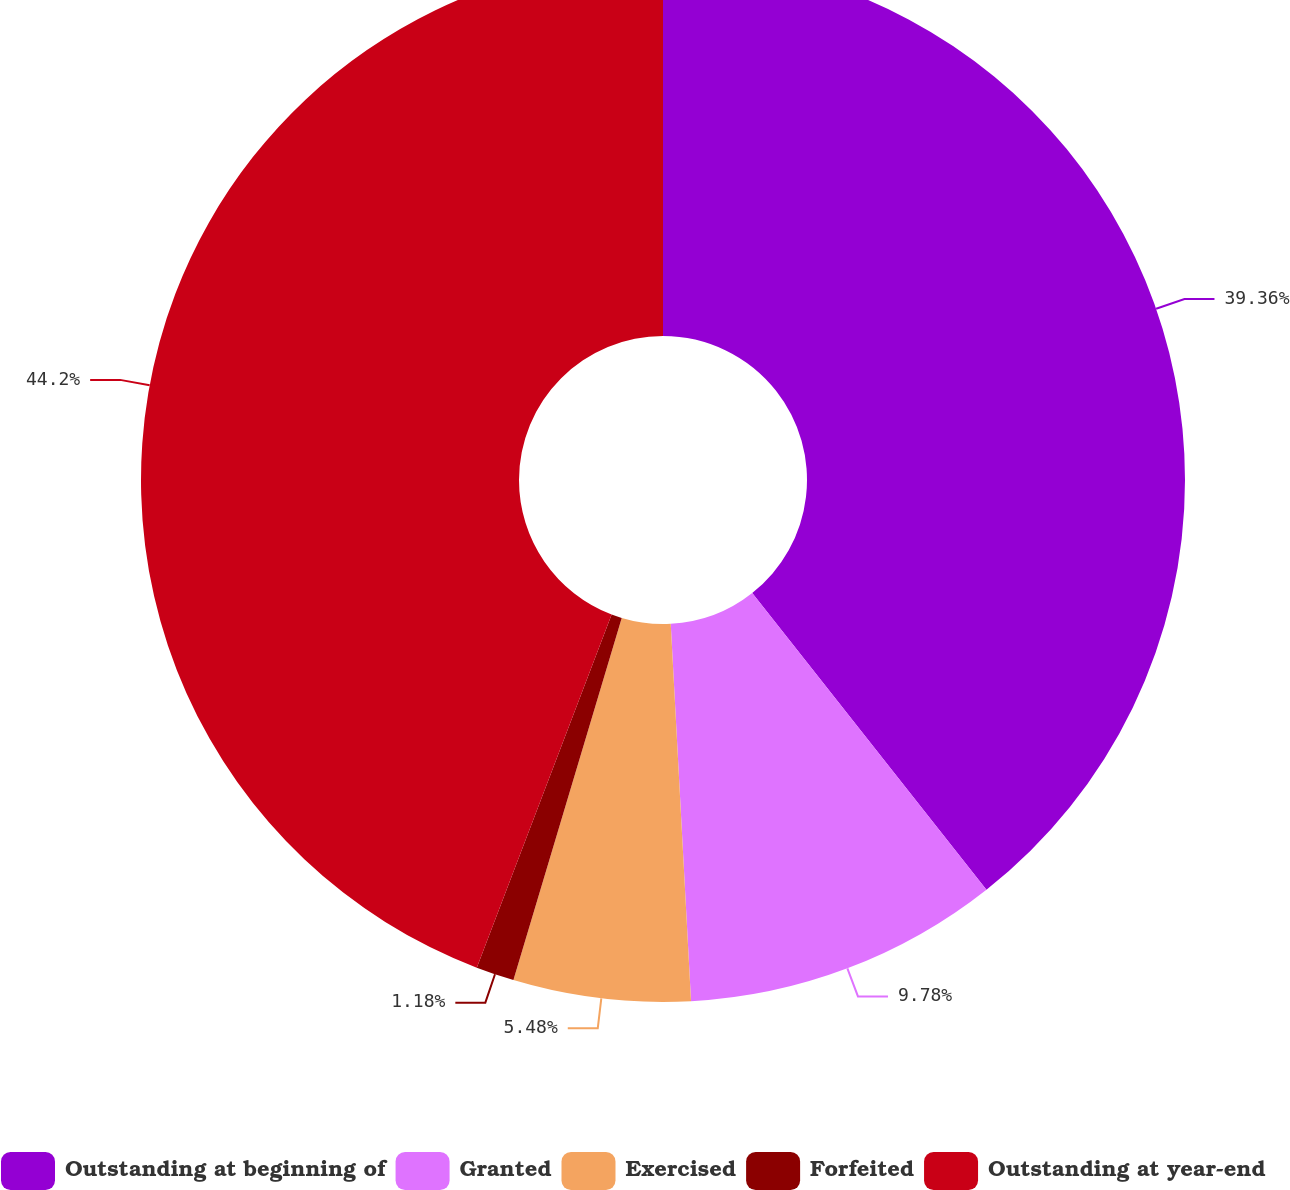Convert chart. <chart><loc_0><loc_0><loc_500><loc_500><pie_chart><fcel>Outstanding at beginning of<fcel>Granted<fcel>Exercised<fcel>Forfeited<fcel>Outstanding at year-end<nl><fcel>39.36%<fcel>9.78%<fcel>5.48%<fcel>1.18%<fcel>44.19%<nl></chart> 